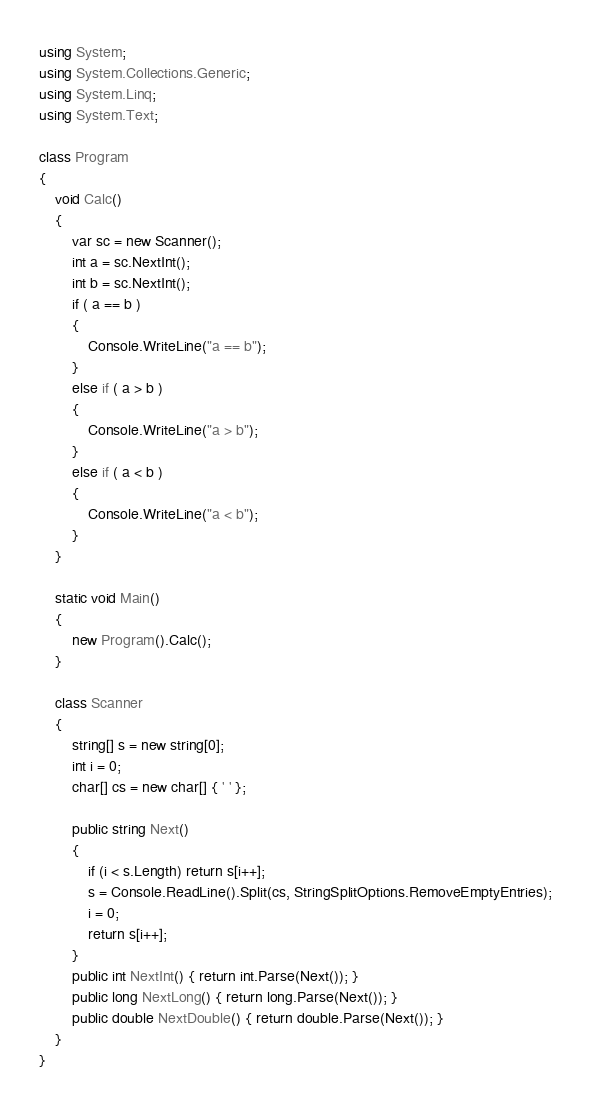Convert code to text. <code><loc_0><loc_0><loc_500><loc_500><_C#_>using System;
using System.Collections.Generic;
using System.Linq;
using System.Text;

class Program
{
    void Calc()
    {
        var sc = new Scanner();
        int a = sc.NextInt();
        int b = sc.NextInt();
        if ( a == b )
        {
            Console.WriteLine("a == b");
        }
        else if ( a > b )
        {
            Console.WriteLine("a > b");
        }
        else if ( a < b )
        {
            Console.WriteLine("a < b");
        }
    }

    static void Main()
    {
        new Program().Calc();
    }

    class Scanner
    {
        string[] s = new string[0];
        int i = 0;
        char[] cs = new char[] { ' ' };

        public string Next()
        {
            if (i < s.Length) return s[i++];
            s = Console.ReadLine().Split(cs, StringSplitOptions.RemoveEmptyEntries);
            i = 0;
            return s[i++];
        }
        public int NextInt() { return int.Parse(Next()); }
        public long NextLong() { return long.Parse(Next()); }
        public double NextDouble() { return double.Parse(Next()); }
    }
}</code> 